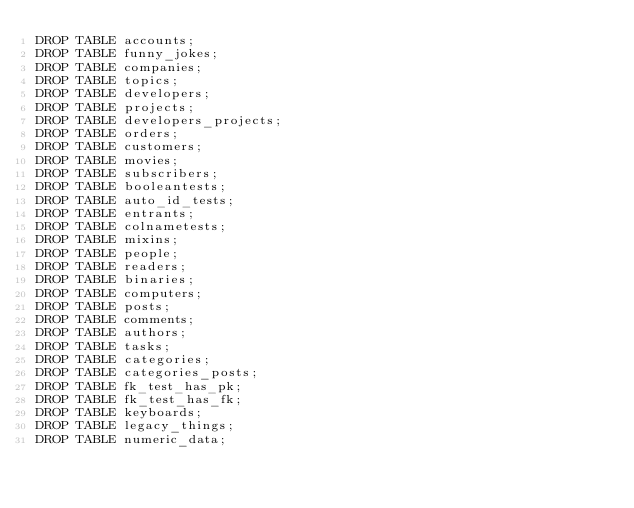<code> <loc_0><loc_0><loc_500><loc_500><_SQL_>DROP TABLE accounts;
DROP TABLE funny_jokes;
DROP TABLE companies;
DROP TABLE topics;
DROP TABLE developers;
DROP TABLE projects;
DROP TABLE developers_projects;
DROP TABLE orders;
DROP TABLE customers;
DROP TABLE movies;
DROP TABLE subscribers;
DROP TABLE booleantests;
DROP TABLE auto_id_tests;
DROP TABLE entrants;
DROP TABLE colnametests;
DROP TABLE mixins;
DROP TABLE people;
DROP TABLE readers;
DROP TABLE binaries;
DROP TABLE computers;
DROP TABLE posts;
DROP TABLE comments;
DROP TABLE authors;
DROP TABLE tasks;
DROP TABLE categories;
DROP TABLE categories_posts;
DROP TABLE fk_test_has_pk;
DROP TABLE fk_test_has_fk;
DROP TABLE keyboards;
DROP TABLE legacy_things;
DROP TABLE numeric_data;
</code> 